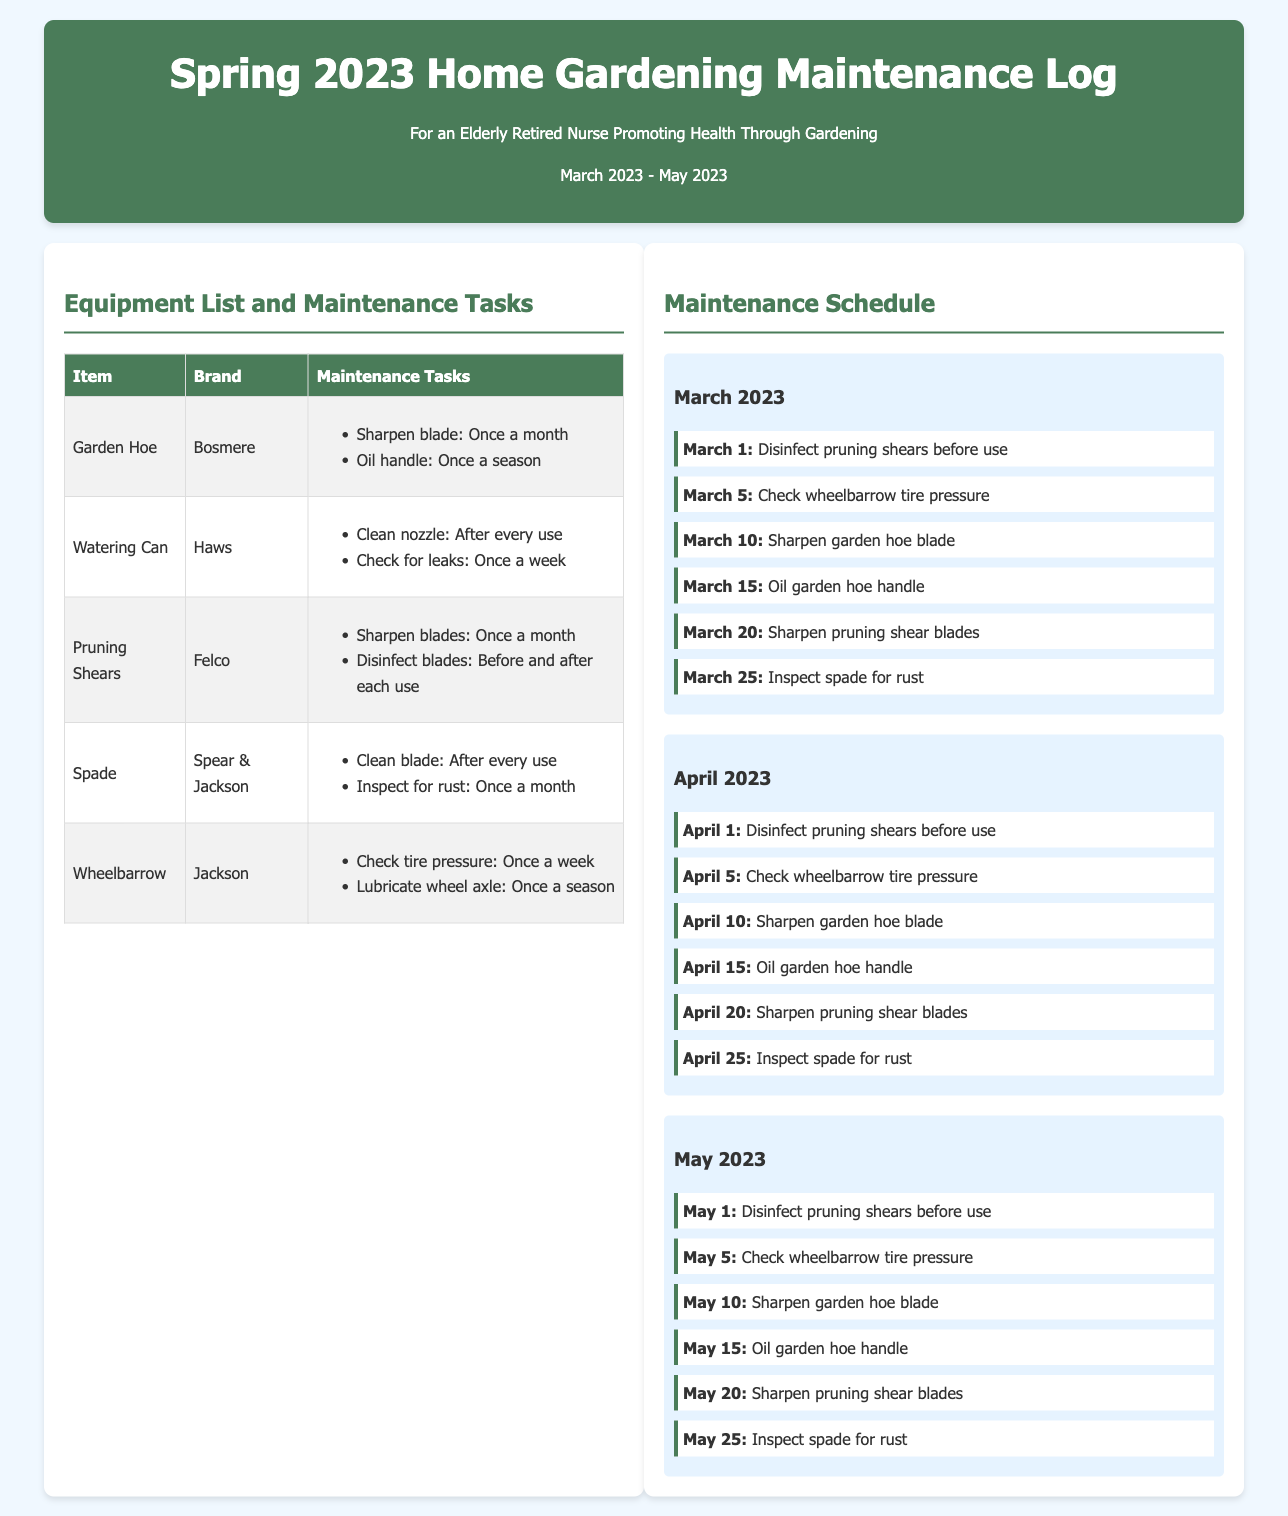What is the title of the document? The title of the document is found in the header section, identifying the purpose of the log.
Answer: Spring 2023 Home Gardening Maintenance Log How many months are covered in the maintenance schedule? The maintenance schedule has tasks listed for each of the three months, March, April, and May.
Answer: 3 What maintenance task is scheduled for May 15? The specific task can be found in the May section of the maintenance schedule.
Answer: Oil garden hoe handle Which brand is the Garden Hoe? The brand associated with the Garden Hoe is explicitly listed in the equipment table.
Answer: Bosmere How often should the watering can nozzle be cleaned? The cleaning frequency for the watering can nozzle appears in the maintenance tasks section.
Answer: After every use What is the task for April 25? This information can be directly retrieved from the April section of the maintenance schedule.
Answer: Inspect spade for rust How many items are listed in the equipment table? The total number of items is indicated within the table under the equipment list.
Answer: 5 What is the color of the header background? The color of the header background is specified in the document's style section.
Answer: #4a7c59 